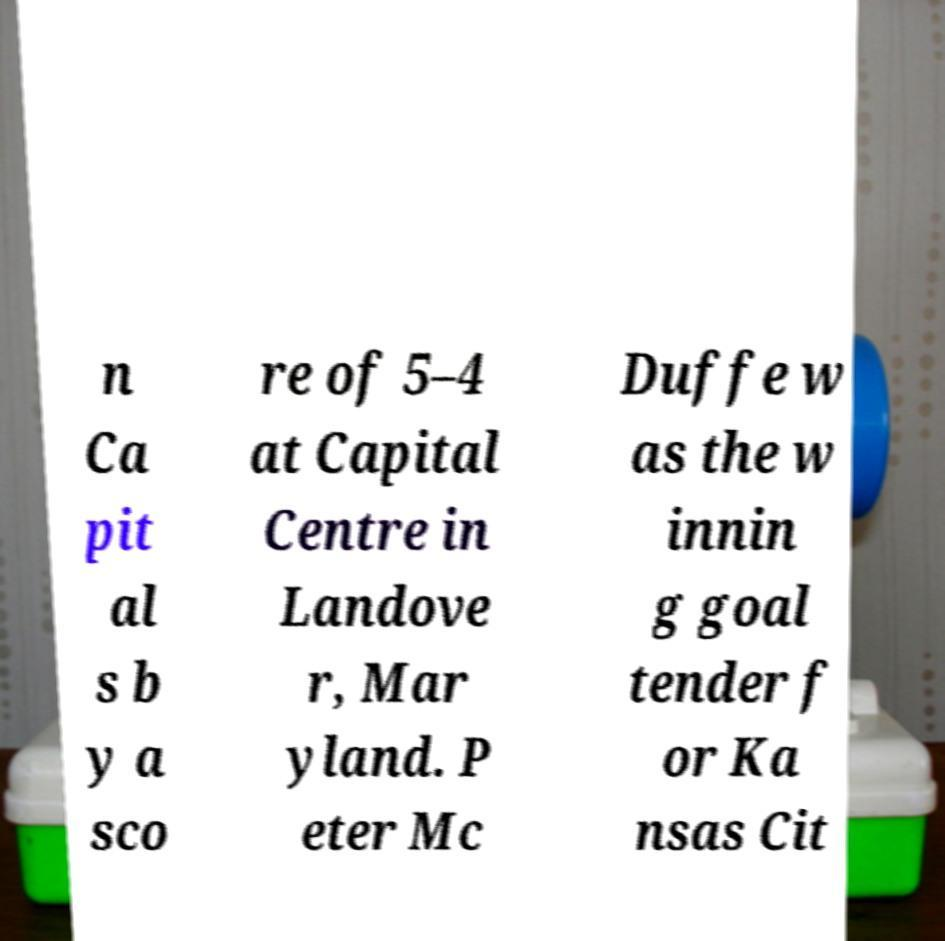Could you assist in decoding the text presented in this image and type it out clearly? n Ca pit al s b y a sco re of 5–4 at Capital Centre in Landove r, Mar yland. P eter Mc Duffe w as the w innin g goal tender f or Ka nsas Cit 